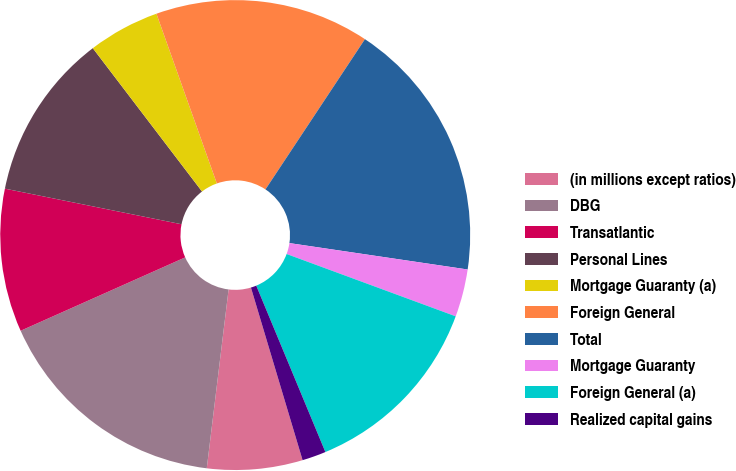<chart> <loc_0><loc_0><loc_500><loc_500><pie_chart><fcel>(in millions except ratios)<fcel>DBG<fcel>Transatlantic<fcel>Personal Lines<fcel>Mortgage Guaranty (a)<fcel>Foreign General<fcel>Total<fcel>Mortgage Guaranty<fcel>Foreign General (a)<fcel>Realized capital gains<nl><fcel>6.56%<fcel>16.39%<fcel>9.84%<fcel>11.47%<fcel>4.92%<fcel>14.75%<fcel>18.03%<fcel>3.28%<fcel>13.11%<fcel>1.64%<nl></chart> 